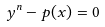<formula> <loc_0><loc_0><loc_500><loc_500>y ^ { n } - p ( x ) = 0</formula> 